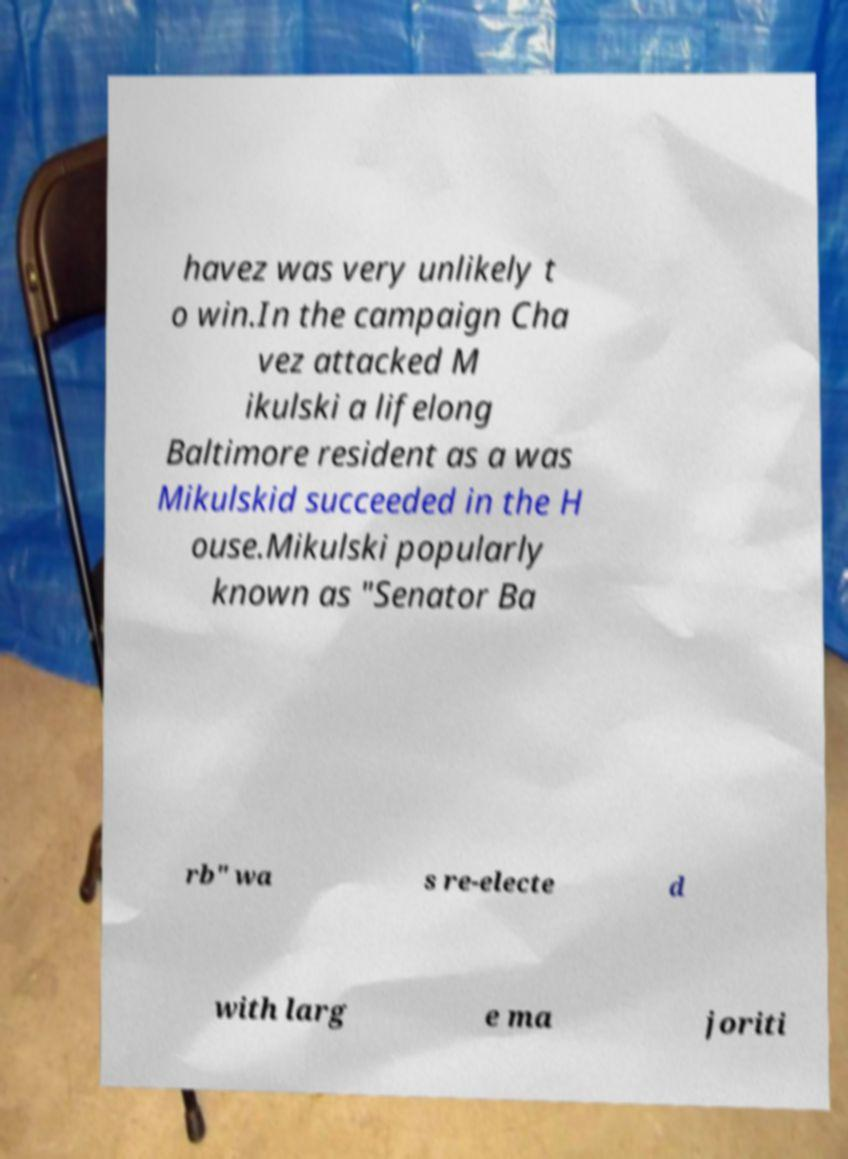I need the written content from this picture converted into text. Can you do that? havez was very unlikely t o win.In the campaign Cha vez attacked M ikulski a lifelong Baltimore resident as a was Mikulskid succeeded in the H ouse.Mikulski popularly known as "Senator Ba rb" wa s re-electe d with larg e ma joriti 